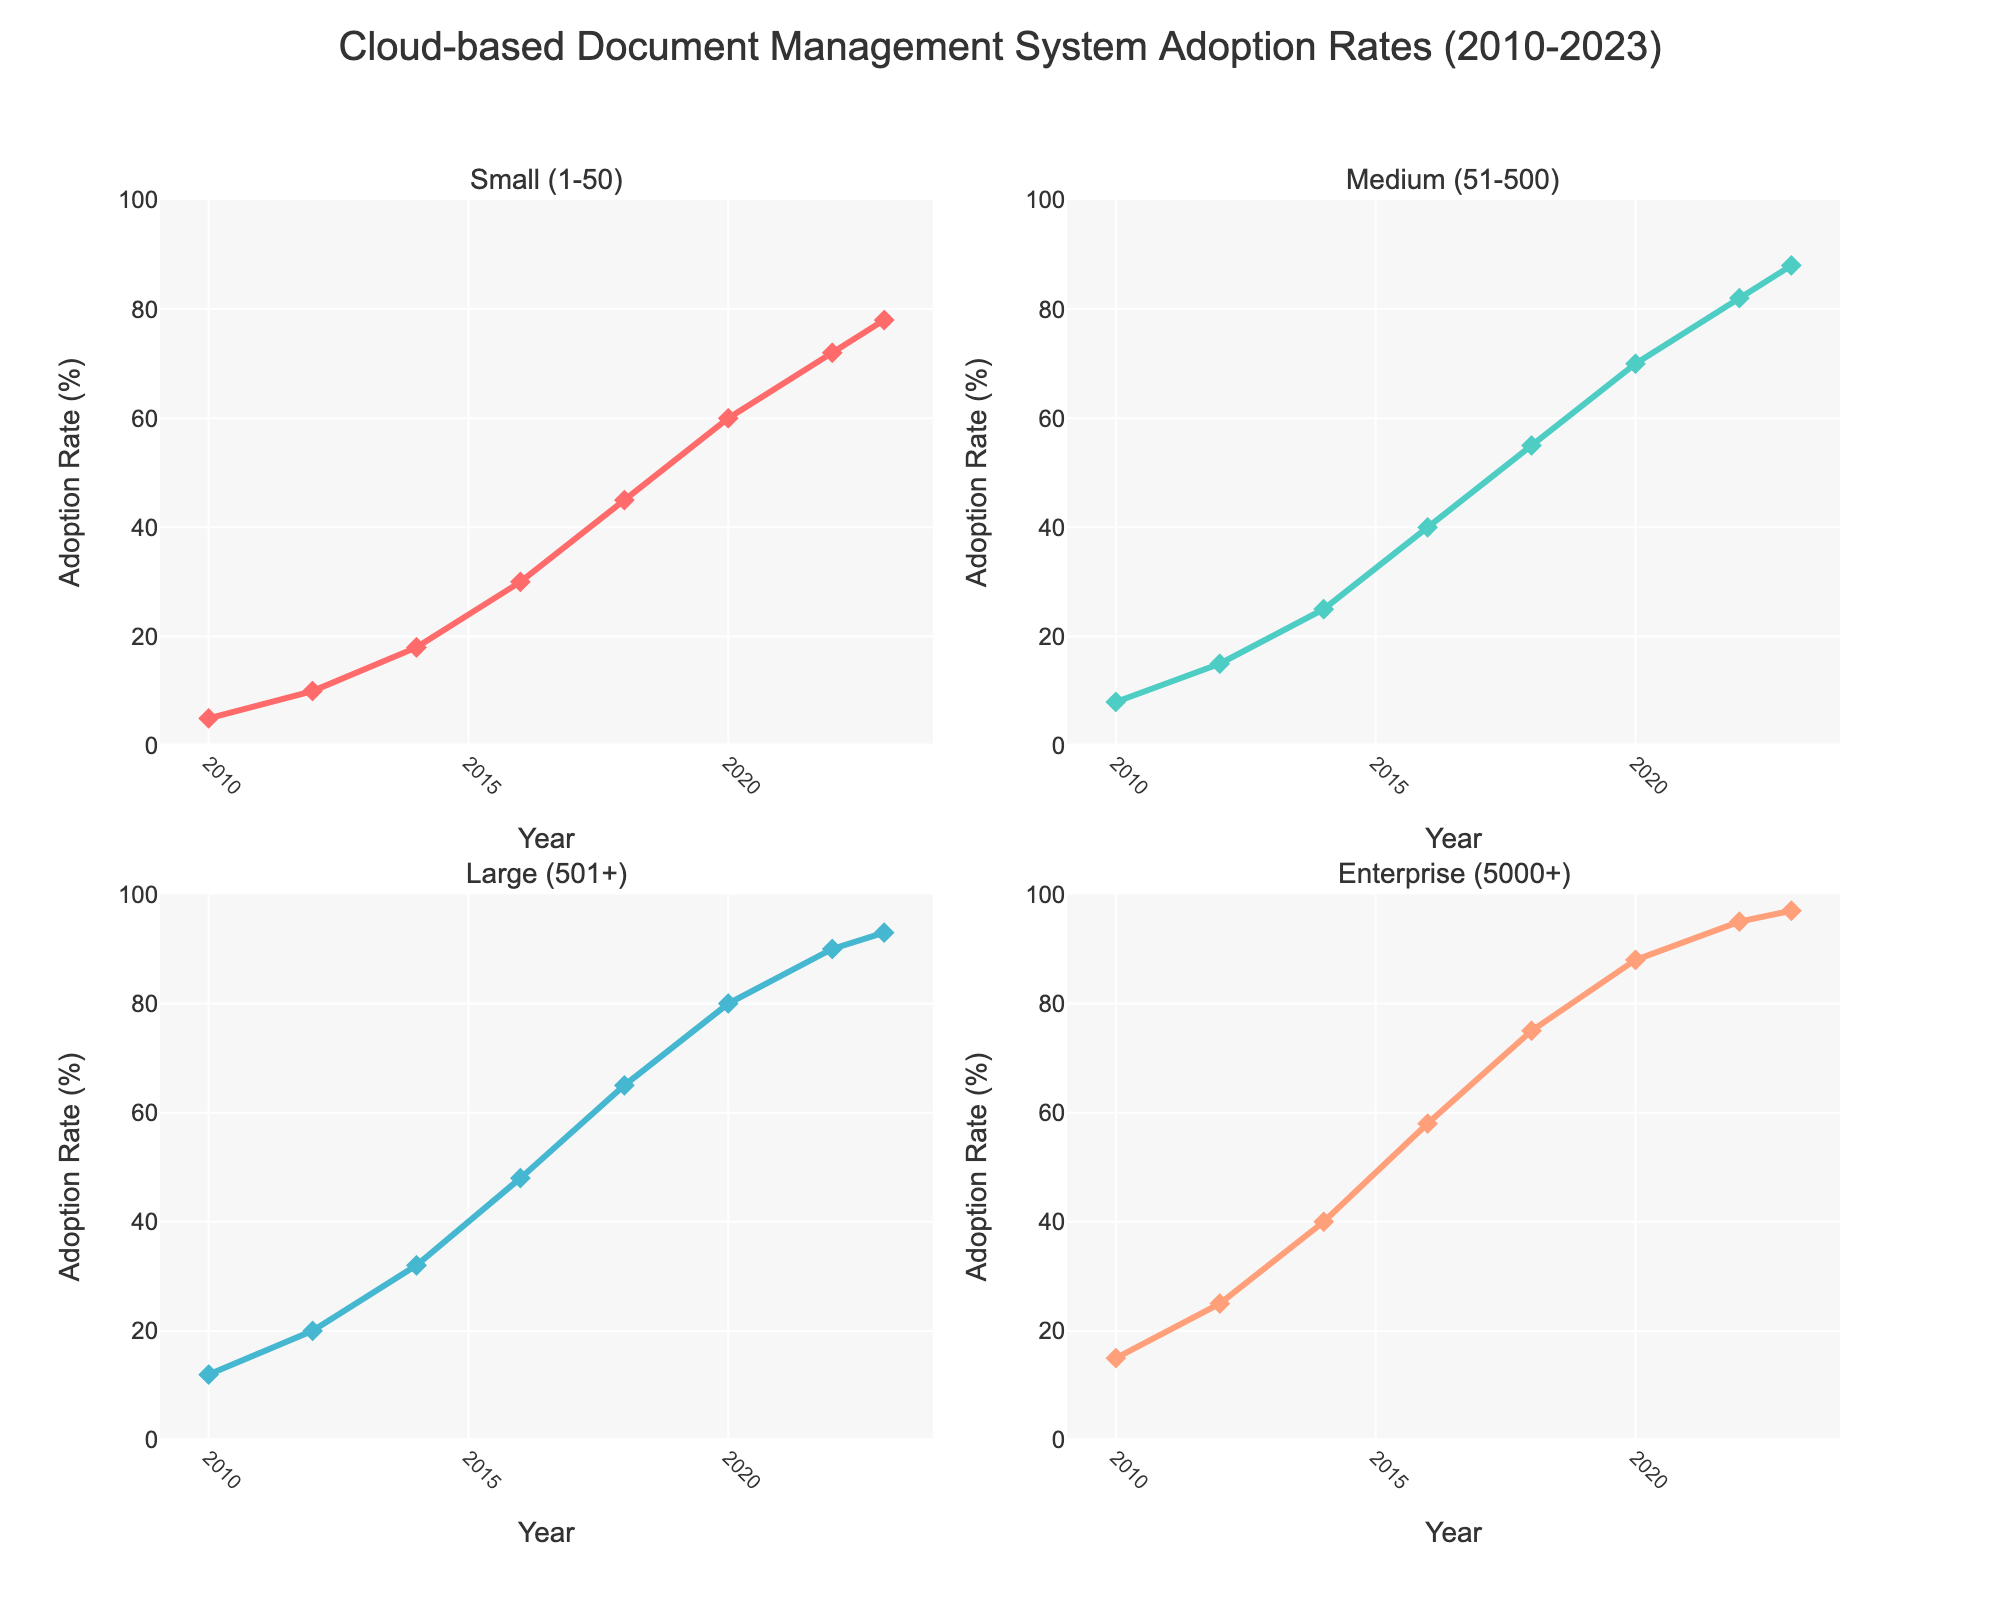What's the title of the figure? The title is located at the top of the plot, indicating the subject of the data presented.
Answer: "Cloud-based Document Management System Adoption Rates (2010-2023)" What is the range of adoption rates for Small companies in 2010? Look at the subplot for Small companies and identify the value on the y-axis for 2010.
Answer: 5% In which year did Medium companies have an adoption rate of 55%? Locate the Medium companies' subplot and follow the plot line to see the year corresponding to 55% on the y-axis.
Answer: 2018 By how much did the adoption rate of Enterprise companies increase between 2012 and 2014? Identify the adoption rates in 2012 and 2014 for Enterprise companies, which are 25% and 40% respectively, and then calculate the difference.
Answer: 15% Which company size had the highest adoption rate in 2020? Check all subplots for the year 2020 and compare the adoption rates: Small (60%), Medium (70%), Large (80%), and Enterprise (88%).
Answer: Enterprise Compare the growth of adoption rates from 2010 to 2023 for Small and Large companies. Which grew faster? Determine the rates for both Small and Large companies in 2010 and 2023: Small (5% to 78%) and Large (12% to 93%). Calculate the increase for each and compare. Small: 73%, Large: 81%.
Answer: Large What is the difference in adoption rates between Medium and Large companies in 2022? Identify the rates for Medium and Large companies in 2022: Medium (82%), Large (90%), and compute the difference.
Answer: 8% Which year shows the steepest increase for Small companies? Observe the plot for Small companies to detect the steepest upward slope. The most noticeable increase is between 2014 (18%) and 2016 (30%).
Answer: 2014-2016 How does the adoption rate for Enterprise companies in 2016 compare to that for Large companies in the same year? Look at the adoption rates for both Enterprise and Large companies in 2016: Enterprise (58%) and Large (48%).
Answer: Enterprise's rate is 10% higher Which subplot has the second highest number of markers overall? Count the markers in each subplot: Small, Medium, Large, and Enterprise companies. They all cover the same date range with the same number of markers; thus, all plots have an equal number of markers.
Answer: All subplots have the same number of markers 